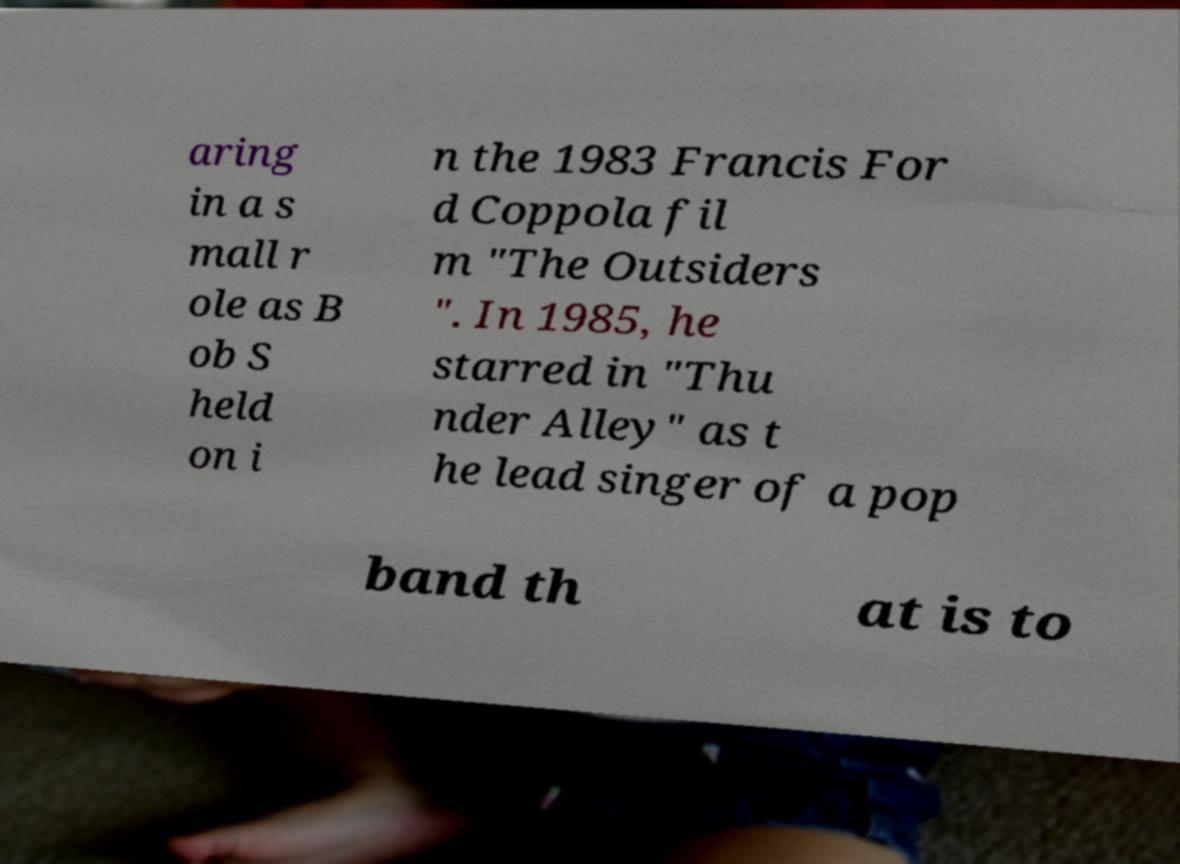I need the written content from this picture converted into text. Can you do that? aring in a s mall r ole as B ob S held on i n the 1983 Francis For d Coppola fil m "The Outsiders ". In 1985, he starred in "Thu nder Alley" as t he lead singer of a pop band th at is to 